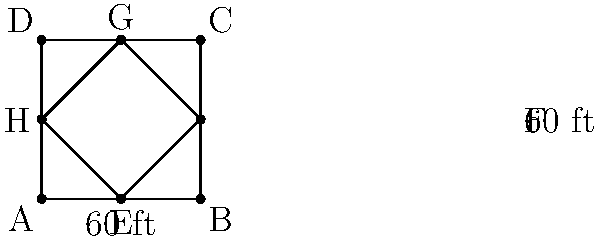As a seasoned softball player, you're familiar with the diamond shape of the field. The diagram shows a softball diamond ABCD with an inscribed diamond EFGH. If the side length of the outer diamond is 60 feet, what is the area of the inner diamond EFGH in square feet? Let's approach this step-by-step:

1) First, we need to recognize that EFGH is a square inscribed in the larger square ABCD.

2) The diagonals of EFGH are the same as the sides of ABCD, which are 60 feet long.

3) In a square, the diagonals bisect each other at right angles. This means that triangle EFO (where O is the center of the square) is a right-angled isosceles triangle.

4) The hypotenuse of this triangle is EF, which is a side of the inner square EFGH. Let's call the length of this side $s$.

5) Using the Pythagorean theorem in triangle EFO:

   $s^2 + s^2 = 60^2$

6) Simplifying:

   $2s^2 = 3600$
   $s^2 = 1800$

7) Taking the square root:

   $s = \sqrt{1800} = 30\sqrt{2}$ feet

8) The area of a square is the square of its side length. So the area of EFGH is:

   $Area = s^2 = (30\sqrt{2})^2 = 1800$ square feet

Therefore, the area of the inner diamond EFGH is 1800 square feet.
Answer: 1800 square feet 